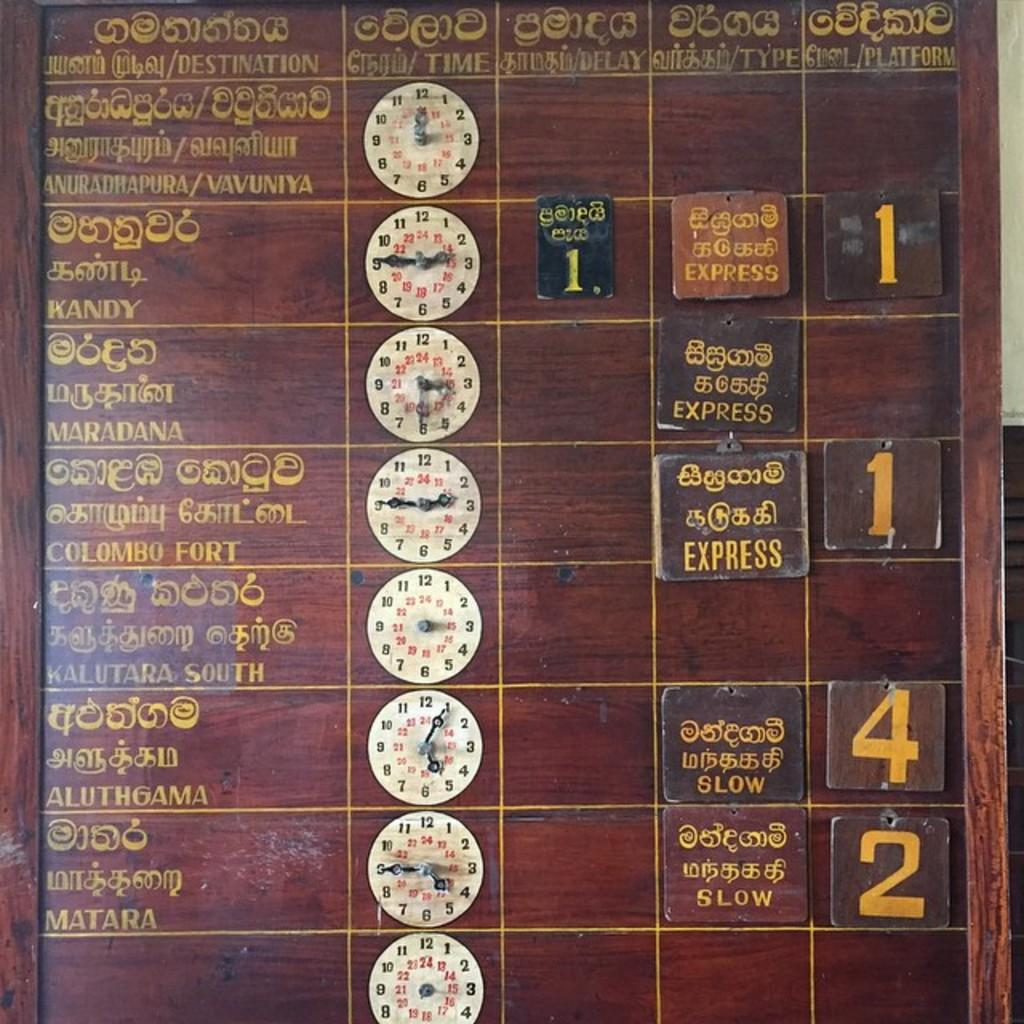<image>
Render a clear and concise summary of the photo. the word express is on some kind of sign 